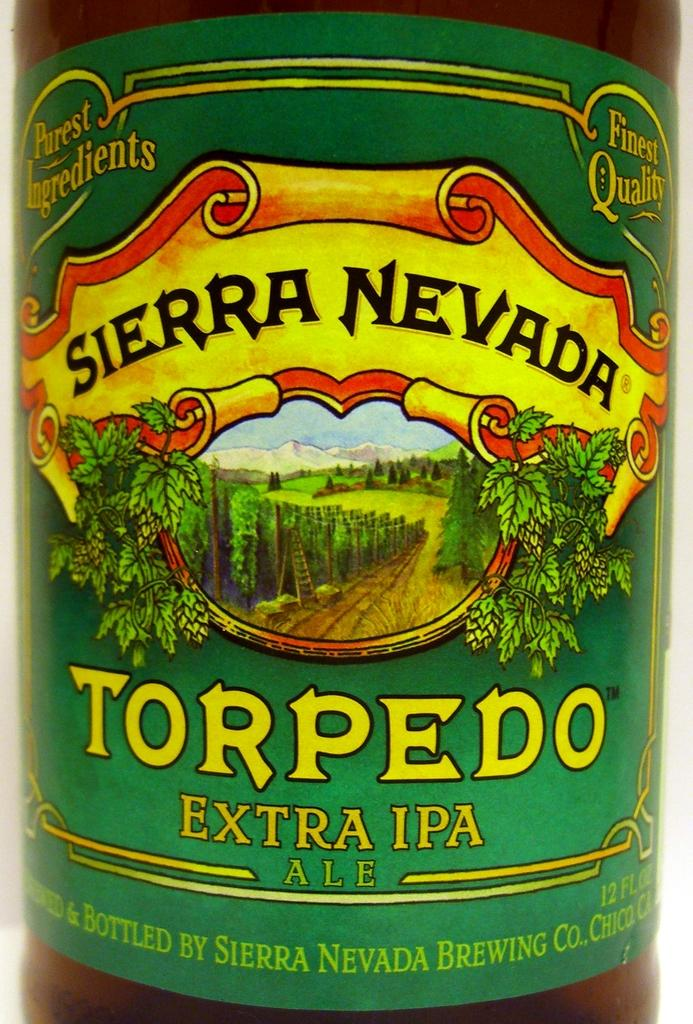What object is present in the image? There is a bottle in the image. What can be seen on the bottle? The bottle has a label. What is depicted on the label? The label features a group of trees, an image of a ladder, and mountains. Are there any words on the label? Yes, there is text on the label. What can be seen in the background of the label? The sky is visible in the label's background. Who is the owner of the spade shown in the image? There is no spade present in the image. What type of coal is used to create the label's design? The label's design does not involve coal; it features a group of trees, an image of a ladder, and mountains. 